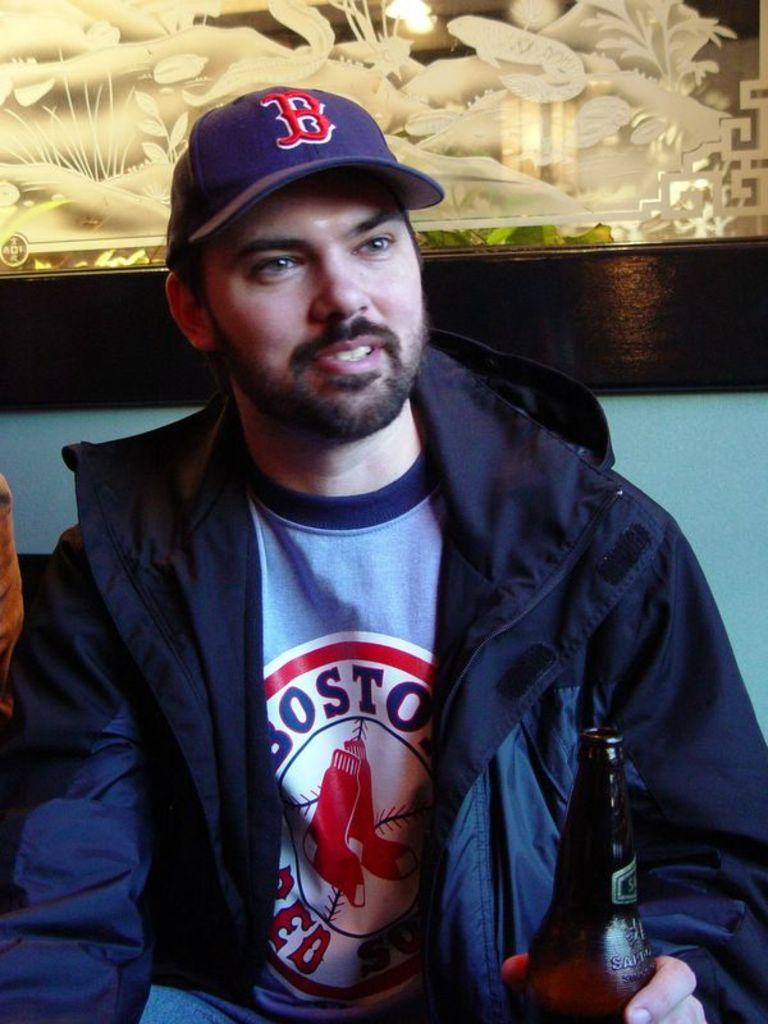What is the sitting person holding in the image? The sitting person is holding a bottle. Can you describe the person's attire? The person is wearing a cap. What can be seen in the background of the image? There is a frame and a wall in the background. What type of temper does the minister have in the image? There is no minister present in the image, and therefore no temper can be observed. What is the person rolling in the image? There is no rolling activity depicted in the image; the person is sitting and holding a bottle. 